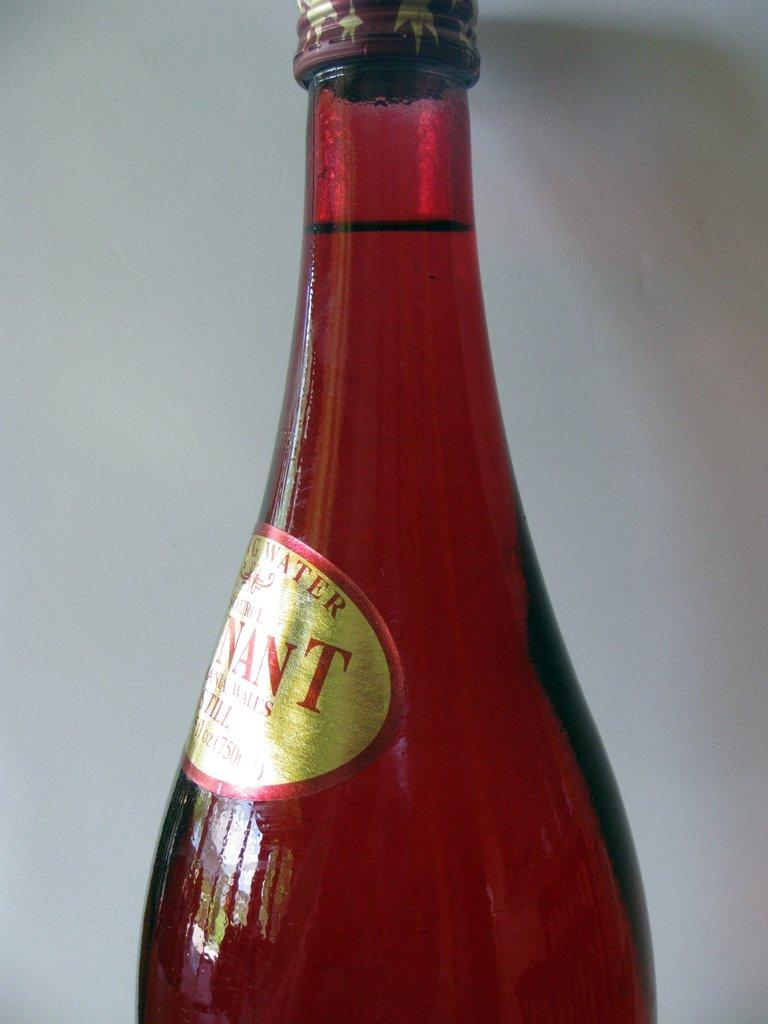<image>
Relay a brief, clear account of the picture shown. Red bottle with a yellow sticker that says "NANT" on it. 